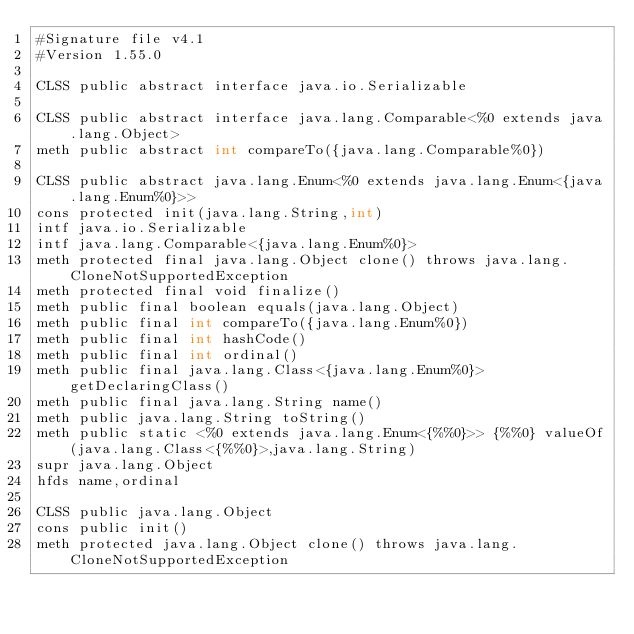<code> <loc_0><loc_0><loc_500><loc_500><_SML_>#Signature file v4.1
#Version 1.55.0

CLSS public abstract interface java.io.Serializable

CLSS public abstract interface java.lang.Comparable<%0 extends java.lang.Object>
meth public abstract int compareTo({java.lang.Comparable%0})

CLSS public abstract java.lang.Enum<%0 extends java.lang.Enum<{java.lang.Enum%0}>>
cons protected init(java.lang.String,int)
intf java.io.Serializable
intf java.lang.Comparable<{java.lang.Enum%0}>
meth protected final java.lang.Object clone() throws java.lang.CloneNotSupportedException
meth protected final void finalize()
meth public final boolean equals(java.lang.Object)
meth public final int compareTo({java.lang.Enum%0})
meth public final int hashCode()
meth public final int ordinal()
meth public final java.lang.Class<{java.lang.Enum%0}> getDeclaringClass()
meth public final java.lang.String name()
meth public java.lang.String toString()
meth public static <%0 extends java.lang.Enum<{%%0}>> {%%0} valueOf(java.lang.Class<{%%0}>,java.lang.String)
supr java.lang.Object
hfds name,ordinal

CLSS public java.lang.Object
cons public init()
meth protected java.lang.Object clone() throws java.lang.CloneNotSupportedException</code> 